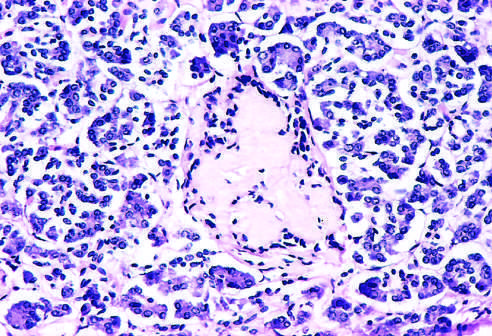s islet inflammation noted at earlier observations?
Answer the question using a single word or phrase. Yes 